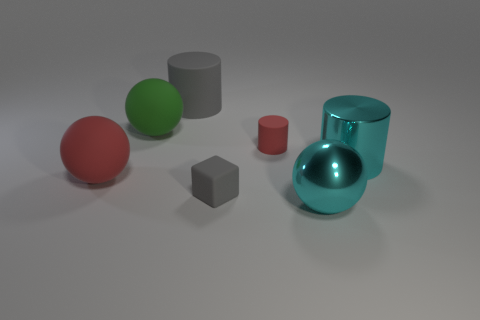Subtract all large cylinders. How many cylinders are left? 1 Add 1 rubber cubes. How many objects exist? 8 Subtract all red balls. How many balls are left? 2 Subtract all spheres. How many objects are left? 4 Add 6 green rubber balls. How many green rubber balls are left? 7 Add 2 tiny red shiny blocks. How many tiny red shiny blocks exist? 2 Subtract 0 purple cylinders. How many objects are left? 7 Subtract 1 spheres. How many spheres are left? 2 Subtract all blue spheres. Subtract all cyan cylinders. How many spheres are left? 3 Subtract all cyan cylinders. How many green balls are left? 1 